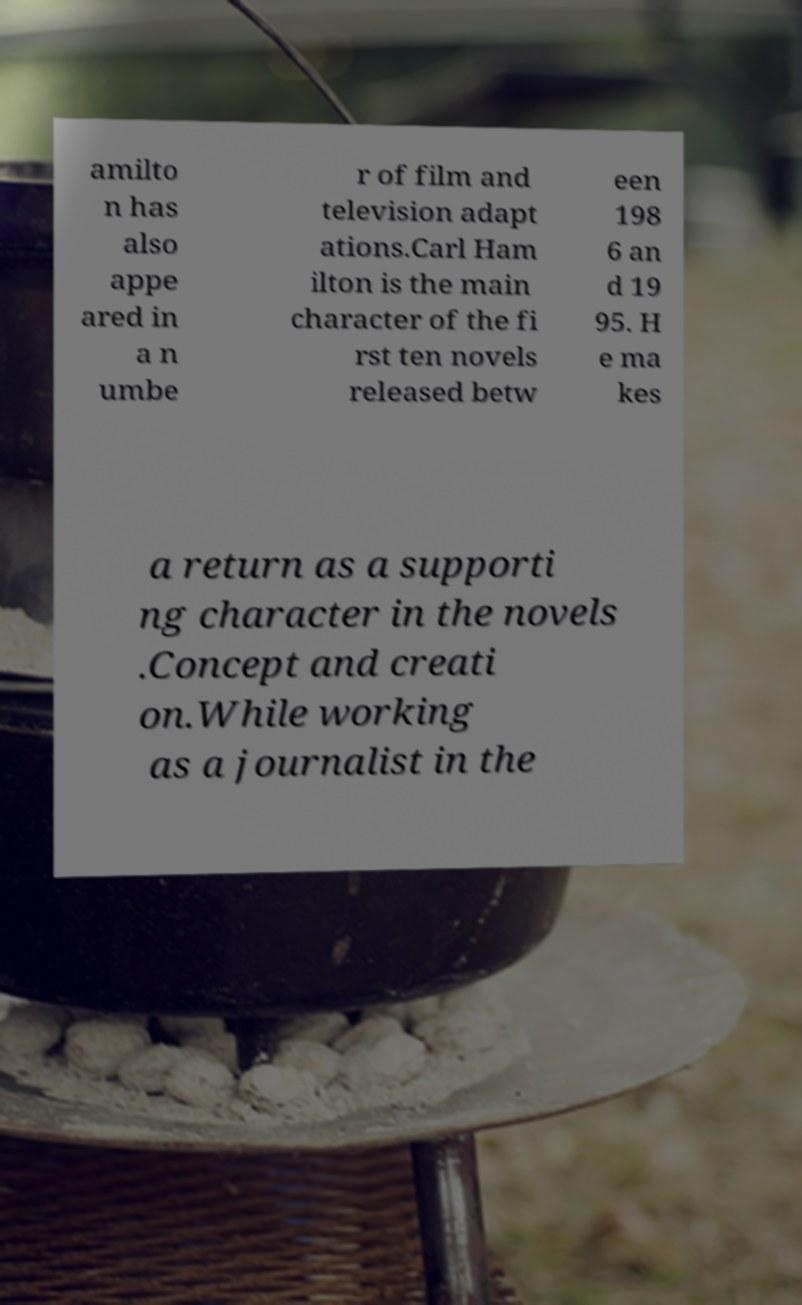Could you assist in decoding the text presented in this image and type it out clearly? amilto n has also appe ared in a n umbe r of film and television adapt ations.Carl Ham ilton is the main character of the fi rst ten novels released betw een 198 6 an d 19 95. H e ma kes a return as a supporti ng character in the novels .Concept and creati on.While working as a journalist in the 